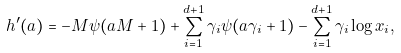Convert formula to latex. <formula><loc_0><loc_0><loc_500><loc_500>h ^ { \prime } ( a ) = - M \psi ( a M + 1 ) + \sum _ { i = 1 } ^ { d + 1 } \gamma _ { i } \psi ( a \gamma _ { i } + 1 ) - \sum _ { i = 1 } ^ { d + 1 } \gamma _ { i } \log x _ { i } ,</formula> 